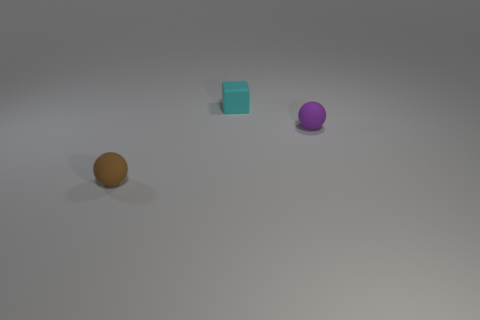What is the size of the matte sphere that is behind the tiny brown thing?
Offer a very short reply. Small. Do the purple matte ball and the matte cube have the same size?
Keep it short and to the point. Yes. Is the number of small brown rubber balls that are on the right side of the small purple ball less than the number of objects to the right of the small cyan rubber block?
Your answer should be very brief. Yes. There is a thing that is both in front of the matte block and to the right of the brown sphere; what size is it?
Provide a succinct answer. Small. Are there any tiny purple matte spheres that are in front of the tiny purple rubber object in front of the cyan matte cube behind the purple sphere?
Keep it short and to the point. No. Are there any tiny cyan things?
Offer a terse response. Yes. Are there more tiny spheres in front of the purple rubber ball than small cyan things in front of the small cyan rubber thing?
Offer a terse response. Yes. What size is the block that is the same material as the brown object?
Offer a terse response. Small. There is a ball that is to the right of the rubber object to the left of the cyan matte cube that is behind the small purple sphere; what size is it?
Your answer should be compact. Small. What is the color of the tiny rubber ball behind the tiny brown object?
Provide a short and direct response. Purple. 